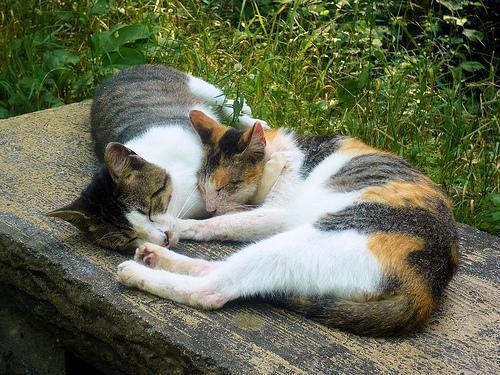How many cats are in the photo?
Give a very brief answer. 2. How many cats are sleeping?
Give a very brief answer. 2. How many eyes are closed?
Give a very brief answer. 4. How many stripes of fur are on the cat?
Give a very brief answer. 7. 